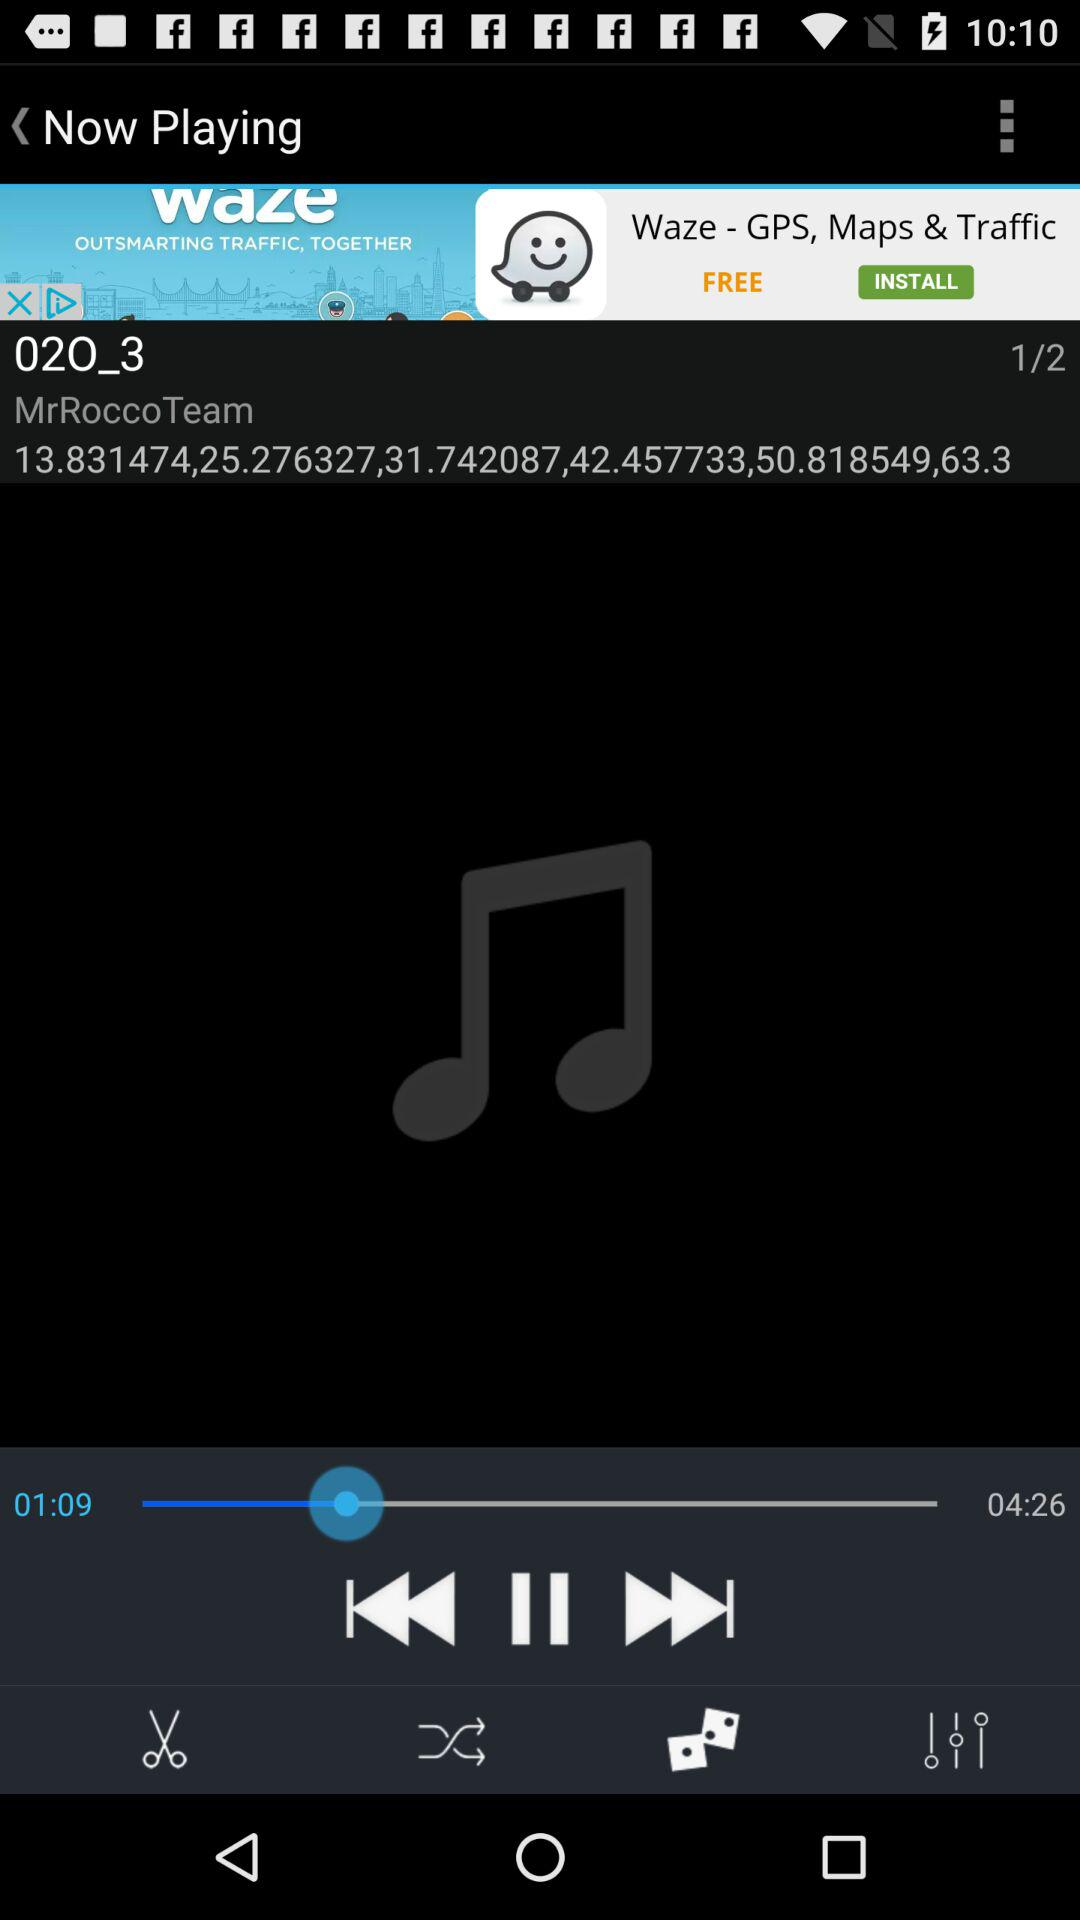What is the time duration of the song currently being played? The time duration of the song currently being played is 4 minutes and 26 seconds. 